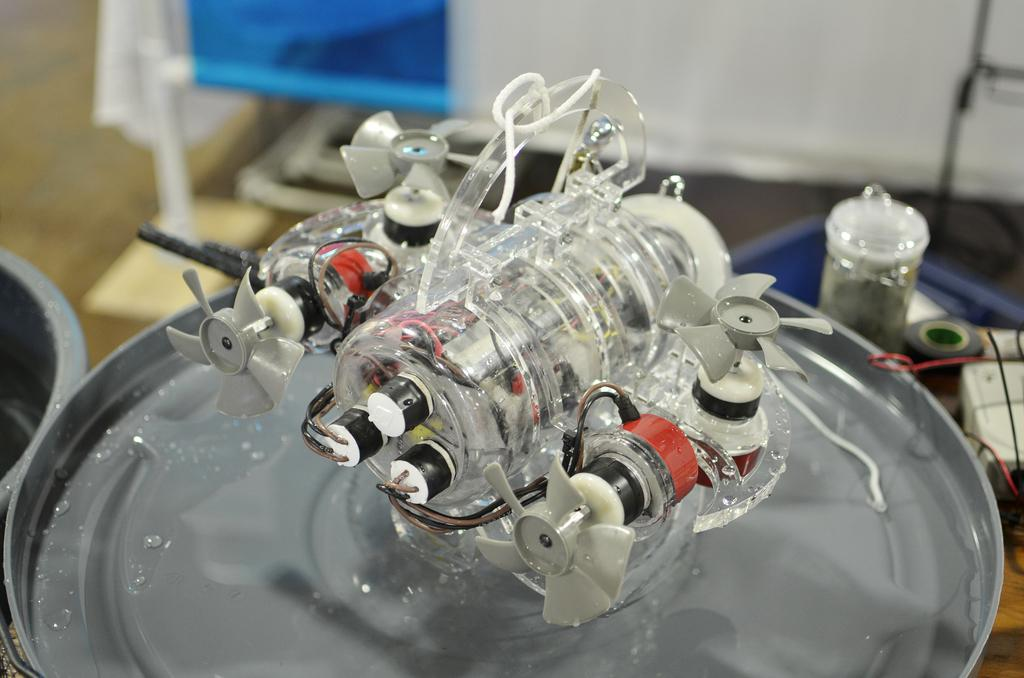What is the primary surface on which objects are placed in the image? There are objects placed on a metal plate in the image. What is the opinion of the bucket in the image? There is no bucket present in the image, so it is not possible to determine its opinion. 